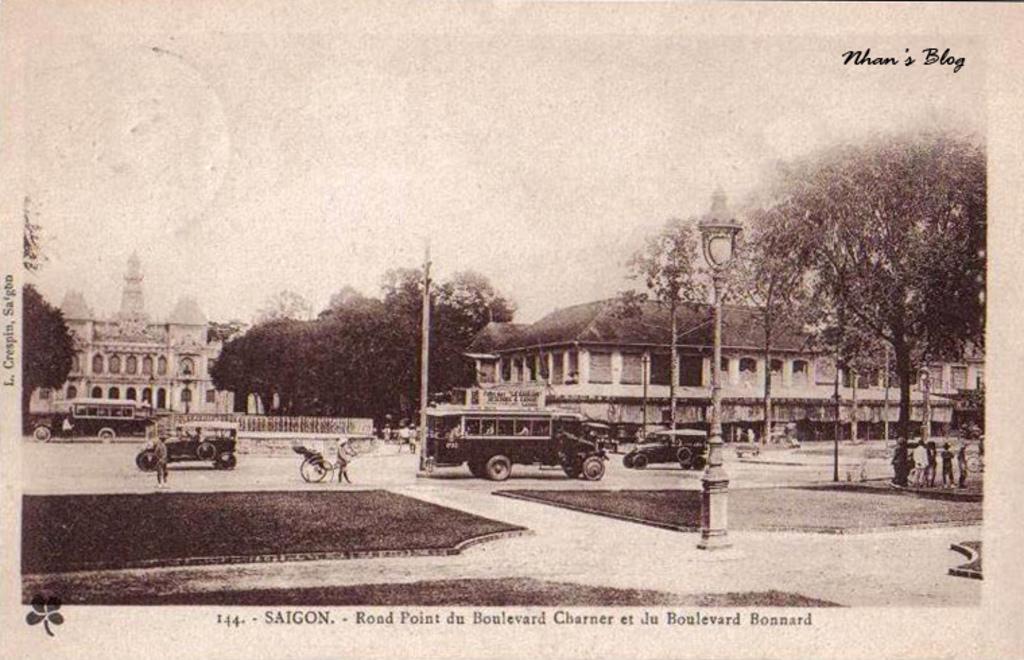What place is this picture of?
Give a very brief answer. Saigon. Who's blog was this picture featured on?
Your answer should be compact. Nhan's. 